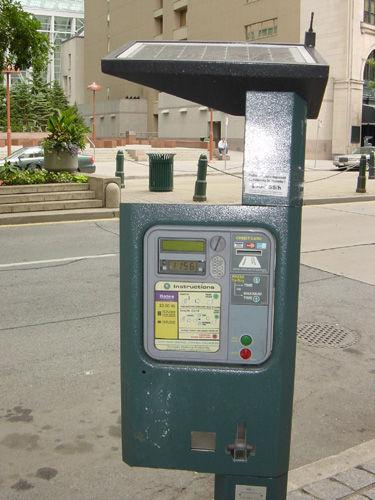What type of plant life is mentioned in the image? There are plotted plants, a plant in a cement planter, and a green plant in the planter on the side of the city road. Identify the two buttons mentioned in the image and their colors. There are red and green buttons on the box. Briefly describe the condition of the street in the image. The street is wet, and there are oily stains and a drain on the city street. State the position and color of the trash can available in the image. There is a green public trash can on the sidewalk. Identify a distinct type of infrastructure in the image background. There's a building in the background with an antenna for radio waves. What type of vehicle is parked in the image and what is its color? There is a silver car and a parked green car in the image. What kind of meter is present in the image, and what does it incorporate? There is an electric parking meter with a solar panel and a digital clock displaying the current time. Enumerate any seating places visible in the image. There are stairs where a person is sitting in a public area; stone steps are also present next to a planter. Mention an example of renewable energy being used in the image scene. A solar panel powers the parking meter. Explain the purpose of the two prominent features on the parking meter. The card slot is for inserting credit cards, and the red and green buttons are for parking meter operations. Describe the emotions of the person in the public area. The person's facial expression cannot be determined from the image. Find the words "card slot" in the text for the image. There is a card slot. Is there a red bicycle leaning against the trash can? The red bicycle can be found right by the green trashcan on the sidewalk. What are the two most prominent colors you see in this image? Green and grey. Is there a dog sitting on the stairs leading to plantings? A dog can be seen sitting and waiting patiently on the steps leading to the plantings. Related to the silver car, is there any object that appears to be a building? Yes, there is a building in the background. Create a funny caption by describing the contrast between nature and urban elements on this city street. When nature met urban: A solitary green plant hopes to be adopted by a parking meter dad! What color are the buttons on the box? Red and green. What is displaying on the digital clock of the parking meter? 1156 From the following options, select the accurate description of the scene:  b. A forest with a waterfall, a bird on a tree, and a tent near a river. Is there a radio wave reception device in the background? If so, describe its position. Yes, an antenna for radio waves is in the background, near the top-left corner of the image. From the given information, identify if there is any standing water on the street. Yes, there are stains and wet spots on the street. Translate the following from English to French: "There is a parking meter that tells you what time it is." Il y a un horodateur qui vous indique l'heure. Can you find a man playing a guitar next to the plant in cement planter? There is a musician playing a guitar beside the plant in the cement planter. Write a detailed sentence about the trash can on the sidewalk. There is a green public trash can on the sidewalk near stone steps and a horizontal metal chain linking two pillars. Where is a flying pigeon around the solar panel? You can spot a flying pigeon near the solar panel that powers the meter. Identify the structure that connects the two pillars on this city street. There is a curved metal chain linking the two pillars. Where can I find a fountain placed near the stone sidewalk and curb? There is a beautiful water fountain next to the stone sidewalk and curb area. What do you think could escalate at the public place? Because of the image's static nature, there is no clear indication of any event that will escalate. Provide a short description of the objects in the scene that are used for parking. Parking meter with a digital clock, buttons, payment slot, and solar panels. List the steps to pay using the parking meter. 1. Check the current time on the digital clock. What is the green box for and what does it have on it? The green box is a parking meter with instructions, buttons, and a digital clock. Where are the umbrellas that people have left near the parking meter? Several umbrellas are left open near the parking meter, protecting it from the rain. Which of these are visible in the image? b. dry desert road 